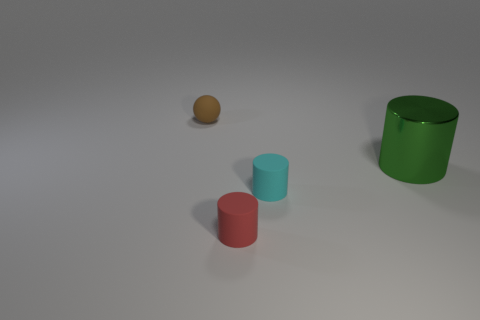Is there anything else that has the same size as the green shiny thing?
Your answer should be very brief. No. The big metallic thing that is the same shape as the small cyan object is what color?
Offer a terse response. Green. Are there any other things that have the same shape as the brown matte object?
Offer a very short reply. No. What shape is the object in front of the tiny cyan rubber thing?
Provide a short and direct response. Cylinder. What number of small red things have the same shape as the green metal thing?
Keep it short and to the point. 1. What number of objects are either small red metallic cylinders or small matte cylinders?
Offer a terse response. 2. What number of tiny brown blocks have the same material as the tiny cyan cylinder?
Give a very brief answer. 0. Is the number of small brown matte spheres less than the number of small matte objects?
Provide a short and direct response. Yes. Do the small thing behind the large green metallic cylinder and the small red cylinder have the same material?
Your response must be concise. Yes. How many cylinders are either small matte objects or big blue things?
Offer a terse response. 2. 